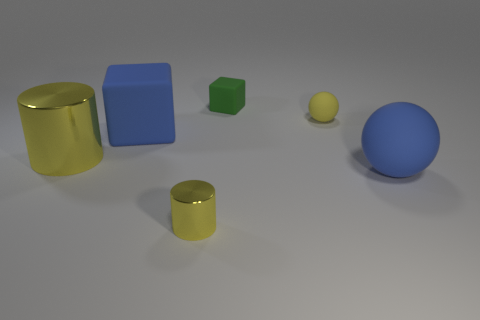Add 3 small matte spheres. How many objects exist? 9 Add 2 big yellow metallic objects. How many big yellow metallic objects exist? 3 Subtract 0 red blocks. How many objects are left? 6 Subtract all small yellow matte objects. Subtract all large blue matte cubes. How many objects are left? 4 Add 2 yellow metallic cylinders. How many yellow metallic cylinders are left? 4 